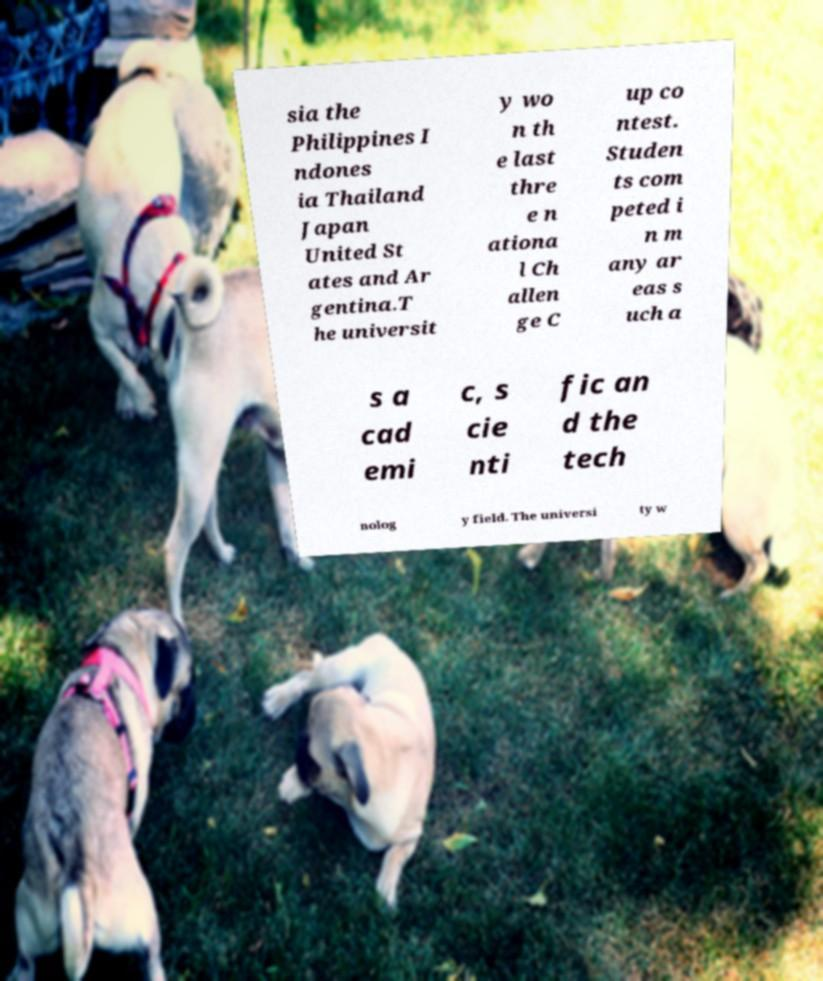There's text embedded in this image that I need extracted. Can you transcribe it verbatim? sia the Philippines I ndones ia Thailand Japan United St ates and Ar gentina.T he universit y wo n th e last thre e n ationa l Ch allen ge C up co ntest. Studen ts com peted i n m any ar eas s uch a s a cad emi c, s cie nti fic an d the tech nolog y field. The universi ty w 